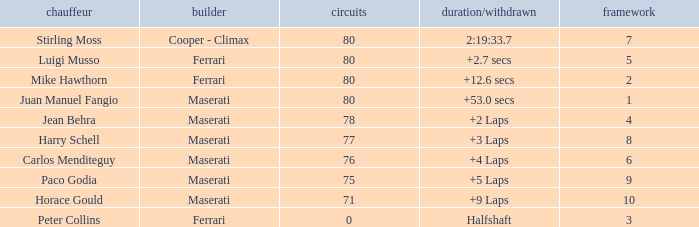I'm looking to parse the entire table for insights. Could you assist me with that? {'header': ['chauffeur', 'builder', 'circuits', 'duration/withdrawn', 'framework'], 'rows': [['Stirling Moss', 'Cooper - Climax', '80', '2:19:33.7', '7'], ['Luigi Musso', 'Ferrari', '80', '+2.7 secs', '5'], ['Mike Hawthorn', 'Ferrari', '80', '+12.6 secs', '2'], ['Juan Manuel Fangio', 'Maserati', '80', '+53.0 secs', '1'], ['Jean Behra', 'Maserati', '78', '+2 Laps', '4'], ['Harry Schell', 'Maserati', '77', '+3 Laps', '8'], ['Carlos Menditeguy', 'Maserati', '76', '+4 Laps', '6'], ['Paco Godia', 'Maserati', '75', '+5 Laps', '9'], ['Horace Gould', 'Maserati', '71', '+9 Laps', '10'], ['Peter Collins', 'Ferrari', '0', 'Halfshaft', '3']]} What's the average Grid for a Maserati with less than 80 laps, and a Time/Retired of +2 laps? 4.0. 